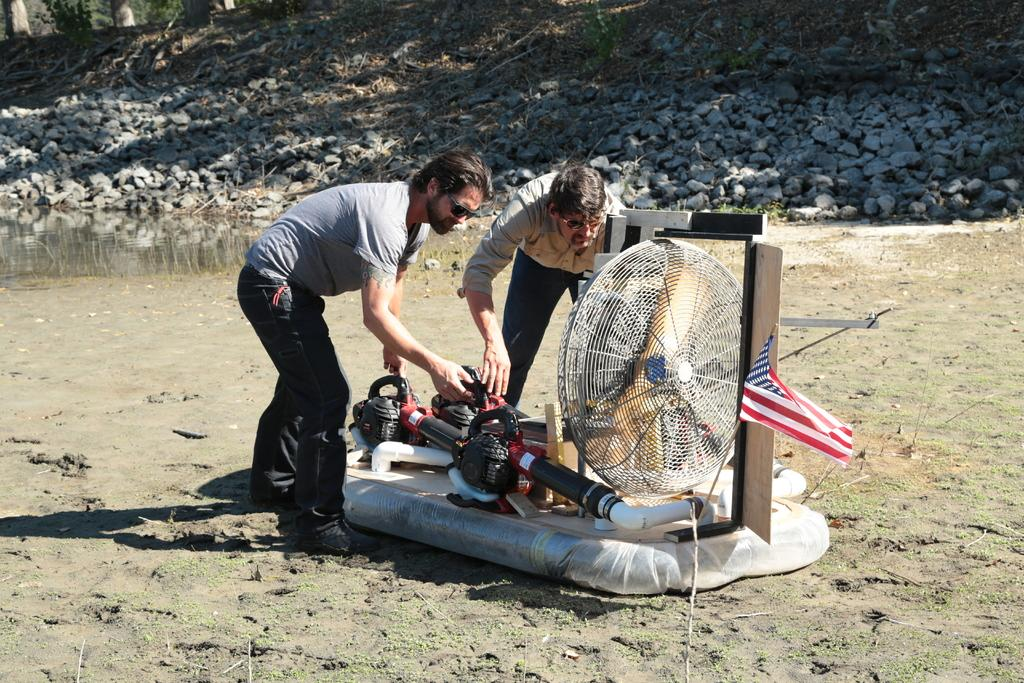How many people are present in the image? There are two people in the image. What are the people doing in the image? The people are in front of some machines. Can you describe any objects in the image besides the people and machines? There is a fan in the image. What can be seen in the background of the image? There are rocks and plants in the background of the image. How long does it take for the stone to fall in the image? There is no stone present in the image, so it is not possible to determine how long it would take for a stone to fall. 